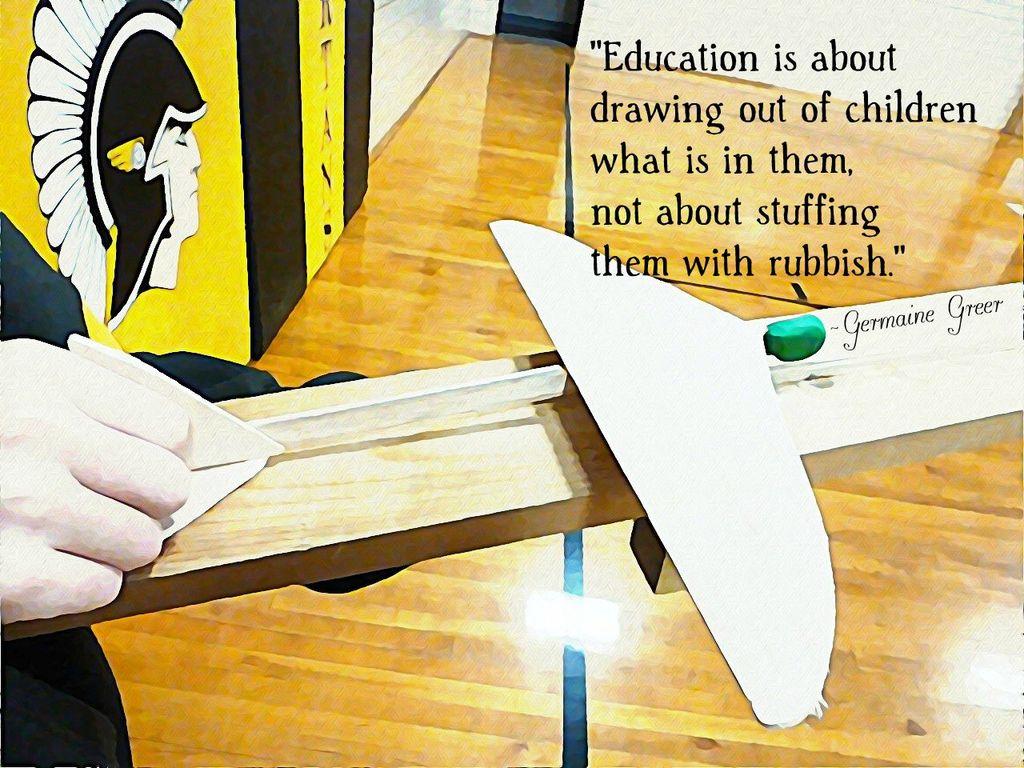Who is this quote by?
Give a very brief answer. Germaine greer. What is education about?
Your response must be concise. Drawing out of children what is in them. 